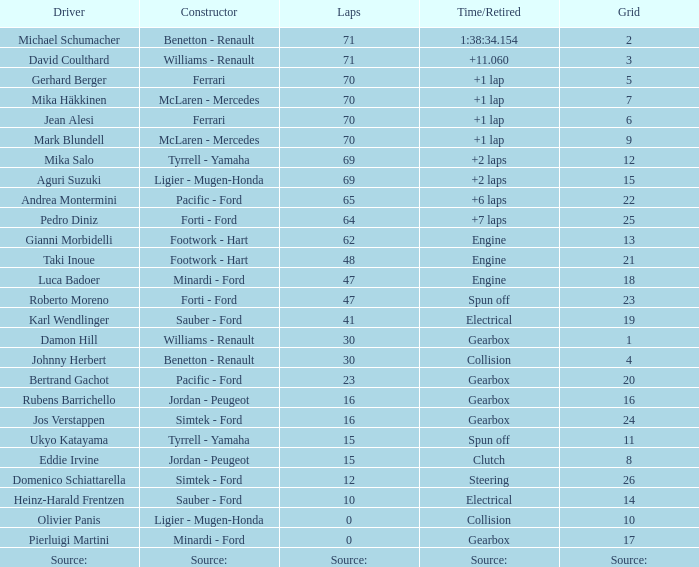In grid 21, what was the count of laps? 48.0. Can you give me this table as a dict? {'header': ['Driver', 'Constructor', 'Laps', 'Time/Retired', 'Grid'], 'rows': [['Michael Schumacher', 'Benetton - Renault', '71', '1:38:34.154', '2'], ['David Coulthard', 'Williams - Renault', '71', '+11.060', '3'], ['Gerhard Berger', 'Ferrari', '70', '+1 lap', '5'], ['Mika Häkkinen', 'McLaren - Mercedes', '70', '+1 lap', '7'], ['Jean Alesi', 'Ferrari', '70', '+1 lap', '6'], ['Mark Blundell', 'McLaren - Mercedes', '70', '+1 lap', '9'], ['Mika Salo', 'Tyrrell - Yamaha', '69', '+2 laps', '12'], ['Aguri Suzuki', 'Ligier - Mugen-Honda', '69', '+2 laps', '15'], ['Andrea Montermini', 'Pacific - Ford', '65', '+6 laps', '22'], ['Pedro Diniz', 'Forti - Ford', '64', '+7 laps', '25'], ['Gianni Morbidelli', 'Footwork - Hart', '62', 'Engine', '13'], ['Taki Inoue', 'Footwork - Hart', '48', 'Engine', '21'], ['Luca Badoer', 'Minardi - Ford', '47', 'Engine', '18'], ['Roberto Moreno', 'Forti - Ford', '47', 'Spun off', '23'], ['Karl Wendlinger', 'Sauber - Ford', '41', 'Electrical', '19'], ['Damon Hill', 'Williams - Renault', '30', 'Gearbox', '1'], ['Johnny Herbert', 'Benetton - Renault', '30', 'Collision', '4'], ['Bertrand Gachot', 'Pacific - Ford', '23', 'Gearbox', '20'], ['Rubens Barrichello', 'Jordan - Peugeot', '16', 'Gearbox', '16'], ['Jos Verstappen', 'Simtek - Ford', '16', 'Gearbox', '24'], ['Ukyo Katayama', 'Tyrrell - Yamaha', '15', 'Spun off', '11'], ['Eddie Irvine', 'Jordan - Peugeot', '15', 'Clutch', '8'], ['Domenico Schiattarella', 'Simtek - Ford', '12', 'Steering', '26'], ['Heinz-Harald Frentzen', 'Sauber - Ford', '10', 'Electrical', '14'], ['Olivier Panis', 'Ligier - Mugen-Honda', '0', 'Collision', '10'], ['Pierluigi Martini', 'Minardi - Ford', '0', 'Gearbox', '17'], ['Source:', 'Source:', 'Source:', 'Source:', 'Source:']]} 